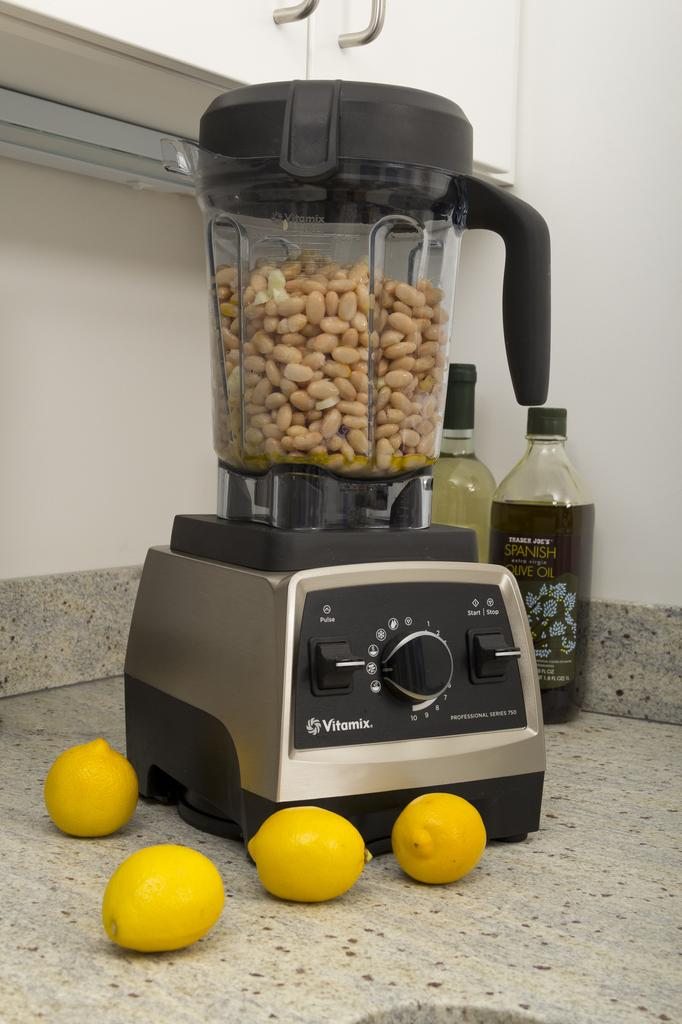<image>
Write a terse but informative summary of the picture. a black vitamix blended with what appears to be nuts inside 